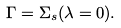Convert formula to latex. <formula><loc_0><loc_0><loc_500><loc_500>\Gamma = \Sigma _ { s } ( \lambda = 0 ) .</formula> 